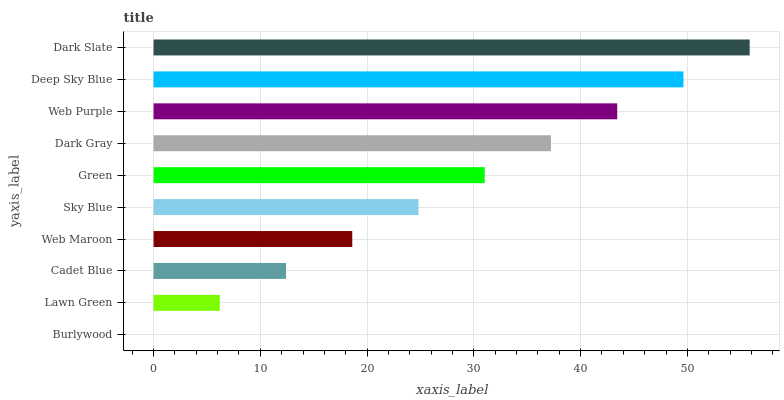Is Burlywood the minimum?
Answer yes or no. Yes. Is Dark Slate the maximum?
Answer yes or no. Yes. Is Lawn Green the minimum?
Answer yes or no. No. Is Lawn Green the maximum?
Answer yes or no. No. Is Lawn Green greater than Burlywood?
Answer yes or no. Yes. Is Burlywood less than Lawn Green?
Answer yes or no. Yes. Is Burlywood greater than Lawn Green?
Answer yes or no. No. Is Lawn Green less than Burlywood?
Answer yes or no. No. Is Green the high median?
Answer yes or no. Yes. Is Sky Blue the low median?
Answer yes or no. Yes. Is Lawn Green the high median?
Answer yes or no. No. Is Lawn Green the low median?
Answer yes or no. No. 